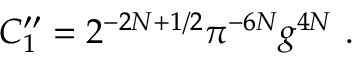Convert formula to latex. <formula><loc_0><loc_0><loc_500><loc_500>C _ { 1 } ^ { \prime \prime } = 2 ^ { - 2 N + 1 / 2 } \pi ^ { - 6 N } g ^ { 4 N } \ .</formula> 